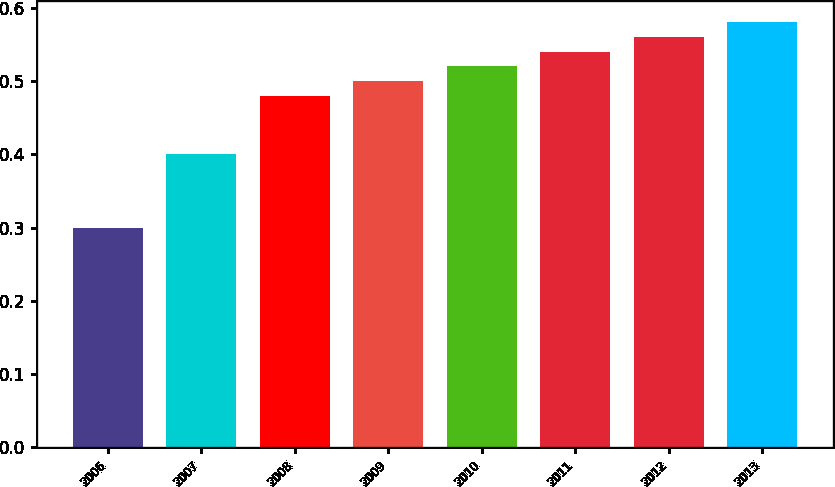<chart> <loc_0><loc_0><loc_500><loc_500><bar_chart><fcel>2006<fcel>2007<fcel>2008<fcel>2009<fcel>2010<fcel>2011<fcel>2012<fcel>2013<nl><fcel>0.3<fcel>0.4<fcel>0.48<fcel>0.5<fcel>0.52<fcel>0.54<fcel>0.56<fcel>0.58<nl></chart> 